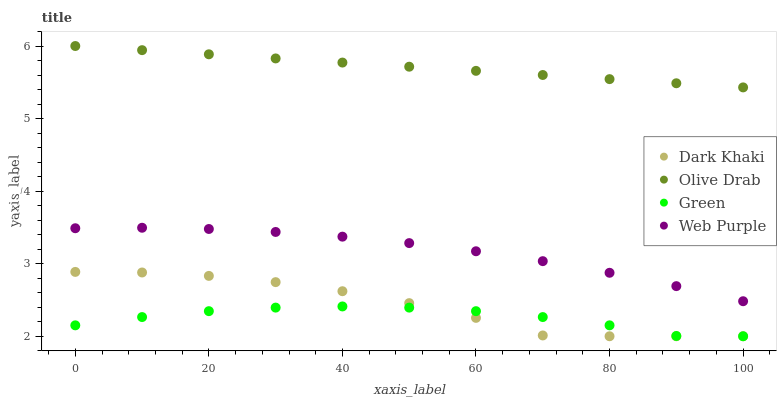Does Green have the minimum area under the curve?
Answer yes or no. Yes. Does Olive Drab have the maximum area under the curve?
Answer yes or no. Yes. Does Web Purple have the minimum area under the curve?
Answer yes or no. No. Does Web Purple have the maximum area under the curve?
Answer yes or no. No. Is Olive Drab the smoothest?
Answer yes or no. Yes. Is Dark Khaki the roughest?
Answer yes or no. Yes. Is Web Purple the smoothest?
Answer yes or no. No. Is Web Purple the roughest?
Answer yes or no. No. Does Dark Khaki have the lowest value?
Answer yes or no. Yes. Does Web Purple have the lowest value?
Answer yes or no. No. Does Olive Drab have the highest value?
Answer yes or no. Yes. Does Web Purple have the highest value?
Answer yes or no. No. Is Green less than Olive Drab?
Answer yes or no. Yes. Is Web Purple greater than Dark Khaki?
Answer yes or no. Yes. Does Dark Khaki intersect Green?
Answer yes or no. Yes. Is Dark Khaki less than Green?
Answer yes or no. No. Is Dark Khaki greater than Green?
Answer yes or no. No. Does Green intersect Olive Drab?
Answer yes or no. No. 